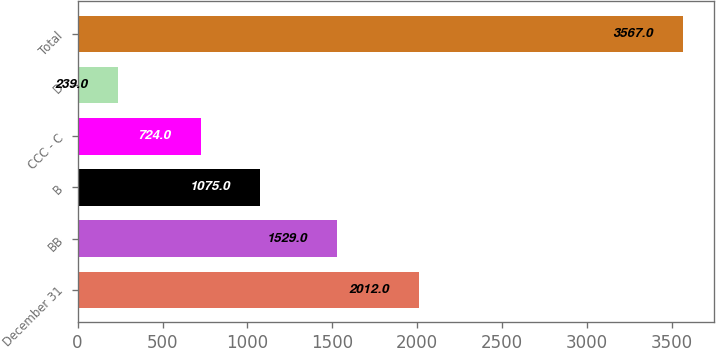<chart> <loc_0><loc_0><loc_500><loc_500><bar_chart><fcel>December 31<fcel>BB<fcel>B<fcel>CCC - C<fcel>D<fcel>Total<nl><fcel>2012<fcel>1529<fcel>1075<fcel>724<fcel>239<fcel>3567<nl></chart> 